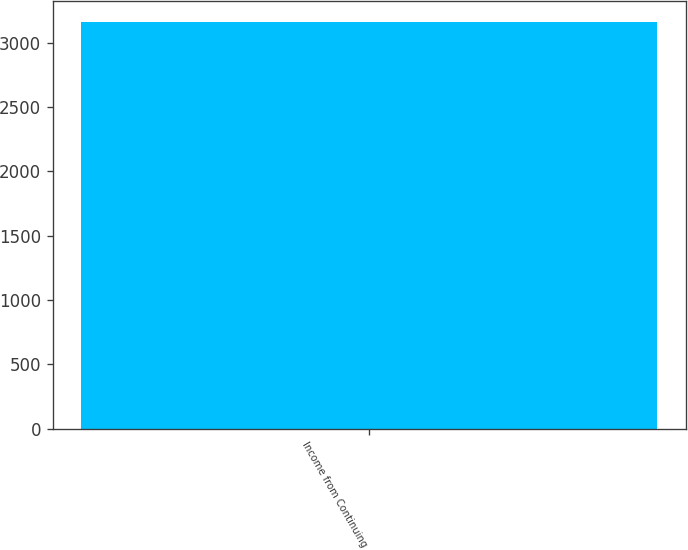Convert chart to OTSL. <chart><loc_0><loc_0><loc_500><loc_500><bar_chart><fcel>Income from Continuing<nl><fcel>3163<nl></chart> 